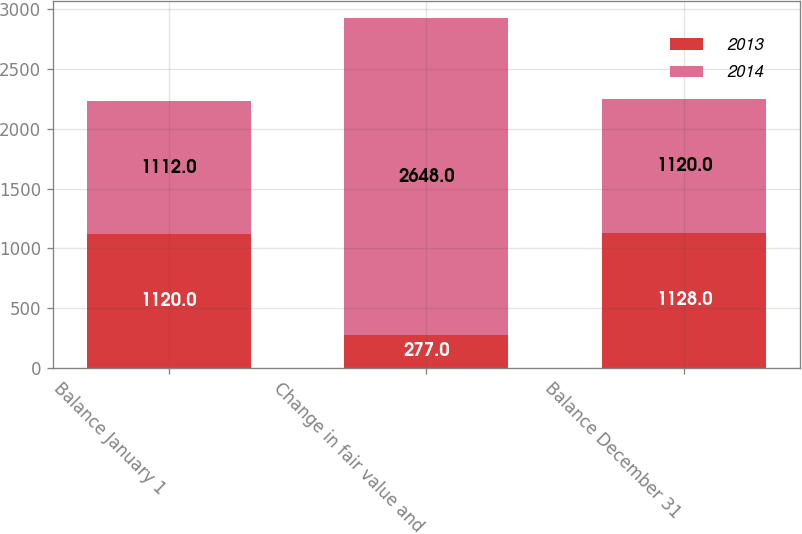Convert chart to OTSL. <chart><loc_0><loc_0><loc_500><loc_500><stacked_bar_chart><ecel><fcel>Balance January 1<fcel>Change in fair value and<fcel>Balance December 31<nl><fcel>2013<fcel>1120<fcel>277<fcel>1128<nl><fcel>2014<fcel>1112<fcel>2648<fcel>1120<nl></chart> 